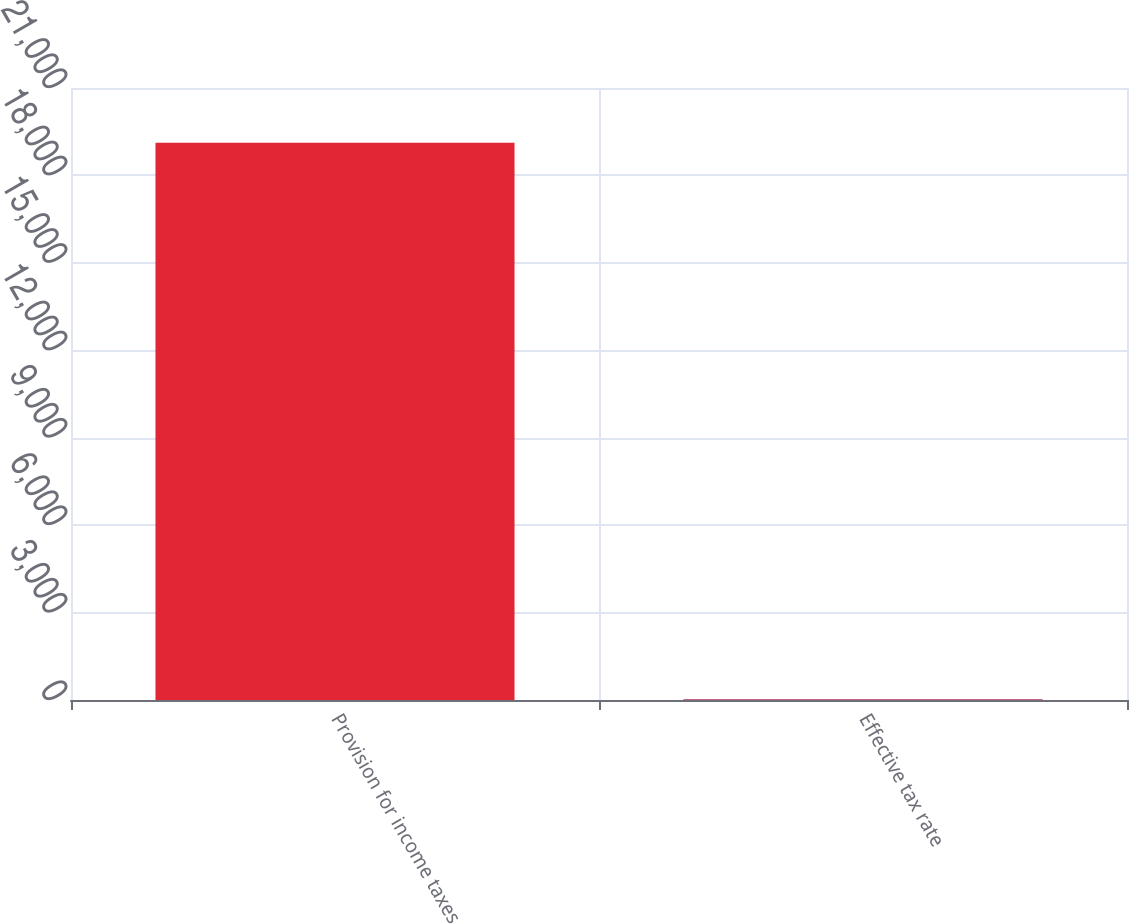Convert chart. <chart><loc_0><loc_0><loc_500><loc_500><bar_chart><fcel>Provision for income taxes<fcel>Effective tax rate<nl><fcel>19121<fcel>26.4<nl></chart> 